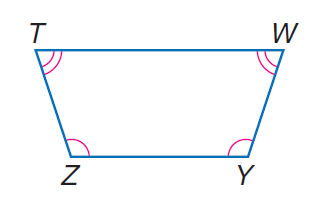Question: isosceles trapezoid T W Y Z with \angle Z \cong \angle Y, m \angle Z = 30 x, \angle T \cong \angle W, and m \angle T = 20 x, find \angle W.
Choices:
A. 62
B. 72
C. 108
D. 118
Answer with the letter. Answer: B Question: isosceles trapezoid T W Y Z with \angle Z \cong \angle Y, m \angle Z = 30 x, \angle T \cong \angle W, and m \angle T = 20 x, find \angle T.
Choices:
A. 62
B. 72
C. 108
D. 118
Answer with the letter. Answer: B Question: isosceles trapezoid T W Y Z with \angle Z \cong \angle Y, m \angle Z = 30 x, \angle T \cong \angle W, and m \angle T = 20 x, find Z.
Choices:
A. 62
B. 72
C. 108
D. 118
Answer with the letter. Answer: C 